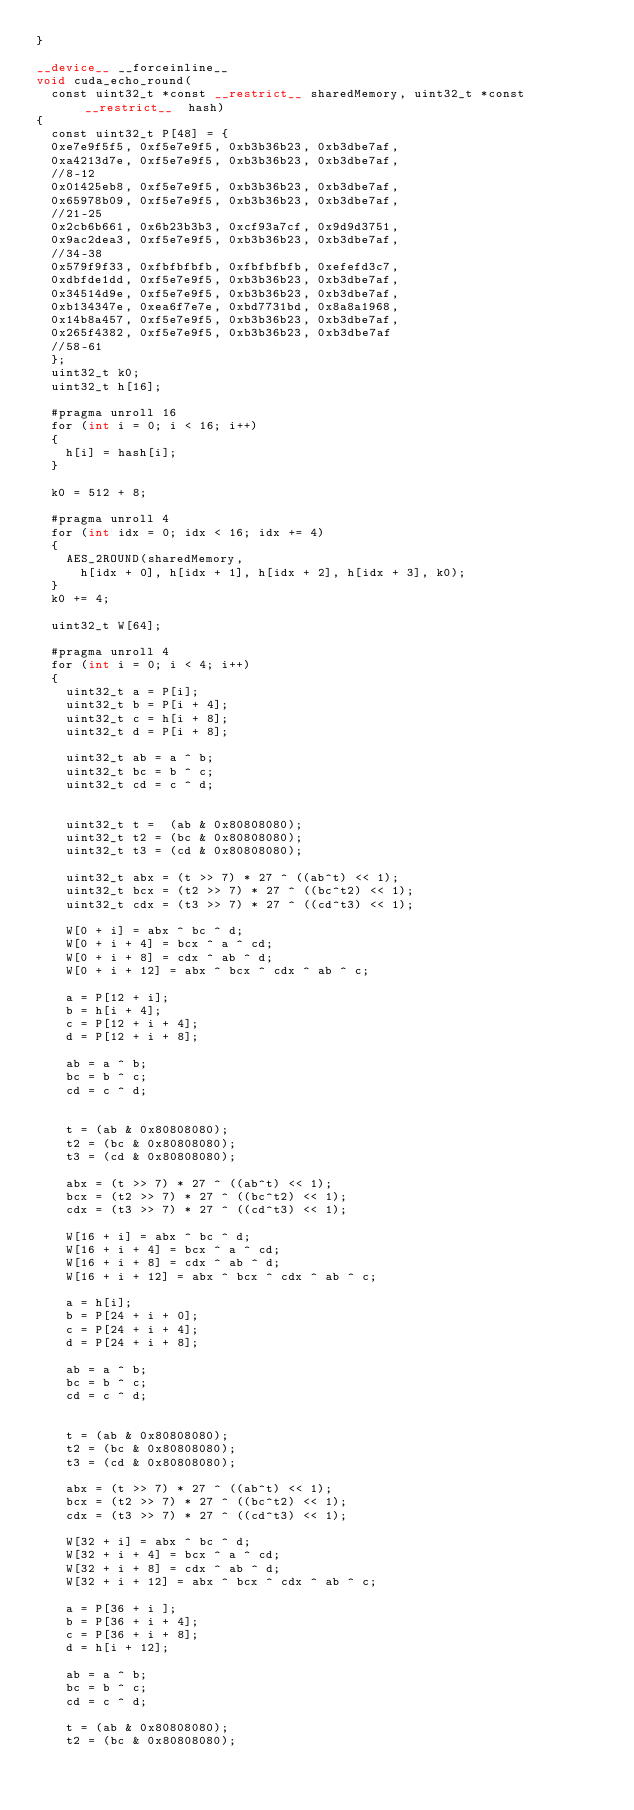<code> <loc_0><loc_0><loc_500><loc_500><_Cuda_>}

__device__ __forceinline__
void cuda_echo_round(
	const uint32_t *const __restrict__ sharedMemory, uint32_t *const __restrict__  hash)
{
	const uint32_t P[48] = {
	0xe7e9f5f5, 0xf5e7e9f5, 0xb3b36b23, 0xb3dbe7af,
	0xa4213d7e, 0xf5e7e9f5, 0xb3b36b23, 0xb3dbe7af,
	//8-12
	0x01425eb8,	0xf5e7e9f5, 0xb3b36b23, 0xb3dbe7af,
	0x65978b09, 0xf5e7e9f5, 0xb3b36b23, 0xb3dbe7af,
	//21-25
	0x2cb6b661, 0x6b23b3b3, 0xcf93a7cf, 0x9d9d3751,
	0x9ac2dea3, 0xf5e7e9f5, 0xb3b36b23, 0xb3dbe7af,
	//34-38
	0x579f9f33, 0xfbfbfbfb, 0xfbfbfbfb, 0xefefd3c7,
	0xdbfde1dd, 0xf5e7e9f5, 0xb3b36b23, 0xb3dbe7af,
	0x34514d9e, 0xf5e7e9f5, 0xb3b36b23, 0xb3dbe7af,
	0xb134347e, 0xea6f7e7e, 0xbd7731bd, 0x8a8a1968,
	0x14b8a457, 0xf5e7e9f5, 0xb3b36b23, 0xb3dbe7af,
	0x265f4382, 0xf5e7e9f5, 0xb3b36b23, 0xb3dbe7af
	//58-61
	};
	uint32_t k0;
	uint32_t h[16];

	#pragma unroll 16
	for (int i = 0; i < 16; i++)
	{
		h[i] = hash[i];
	}

	k0 = 512 + 8;

	#pragma unroll 4
	for (int idx = 0; idx < 16; idx += 4)
	{
		AES_2ROUND(sharedMemory,
			h[idx + 0], h[idx + 1], h[idx + 2], h[idx + 3], k0);
	}
	k0 += 4;

	uint32_t W[64];

	#pragma unroll 4
	for (int i = 0; i < 4; i++)
	{
		uint32_t a = P[i];
		uint32_t b = P[i + 4];
		uint32_t c = h[i + 8];
		uint32_t d = P[i + 8];

		uint32_t ab = a ^ b;
		uint32_t bc = b ^ c;
		uint32_t cd = c ^ d;


		uint32_t t =  (ab & 0x80808080);
		uint32_t t2 = (bc & 0x80808080);
		uint32_t t3 = (cd & 0x80808080);

		uint32_t abx = (t >> 7) * 27 ^ ((ab^t) << 1);
		uint32_t bcx = (t2 >> 7) * 27 ^ ((bc^t2) << 1);
		uint32_t cdx = (t3 >> 7) * 27 ^ ((cd^t3) << 1);

		W[0 + i] = abx ^ bc ^ d;
		W[0 + i + 4] = bcx ^ a ^ cd;
		W[0 + i + 8] = cdx ^ ab ^ d;
		W[0 + i + 12] = abx ^ bcx ^ cdx ^ ab ^ c;

		a = P[12 + i];
		b = h[i + 4];
		c = P[12 + i + 4];
		d = P[12 + i + 8];

		ab = a ^ b;
		bc = b ^ c;
		cd = c ^ d;


		t = (ab & 0x80808080);
		t2 = (bc & 0x80808080);
		t3 = (cd & 0x80808080);

		abx = (t >> 7) * 27 ^ ((ab^t) << 1);
		bcx = (t2 >> 7) * 27 ^ ((bc^t2) << 1);
		cdx = (t3 >> 7) * 27 ^ ((cd^t3) << 1);

		W[16 + i] = abx ^ bc ^ d;
		W[16 + i + 4] = bcx ^ a ^ cd;
		W[16 + i + 8] = cdx ^ ab ^ d;
		W[16 + i + 12] = abx ^ bcx ^ cdx ^ ab ^ c;

		a = h[i];
		b = P[24 + i + 0];
		c = P[24 + i + 4];
		d = P[24 + i + 8];

		ab = a ^ b;
		bc = b ^ c;
		cd = c ^ d;


		t = (ab & 0x80808080);
		t2 = (bc & 0x80808080);
		t3 = (cd & 0x80808080);

		abx = (t >> 7) * 27 ^ ((ab^t) << 1);
		bcx = (t2 >> 7) * 27 ^ ((bc^t2) << 1);
		cdx = (t3 >> 7) * 27 ^ ((cd^t3) << 1);

		W[32 + i] = abx ^ bc ^ d;
		W[32 + i + 4] = bcx ^ a ^ cd;
		W[32 + i + 8] = cdx ^ ab ^ d;
		W[32 + i + 12] = abx ^ bcx ^ cdx ^ ab ^ c;

		a = P[36 + i ];
		b = P[36 + i + 4];
		c = P[36 + i + 8];
		d = h[i + 12];

		ab = a ^ b;
		bc = b ^ c;
		cd = c ^ d;

		t = (ab & 0x80808080);
		t2 = (bc & 0x80808080);</code> 